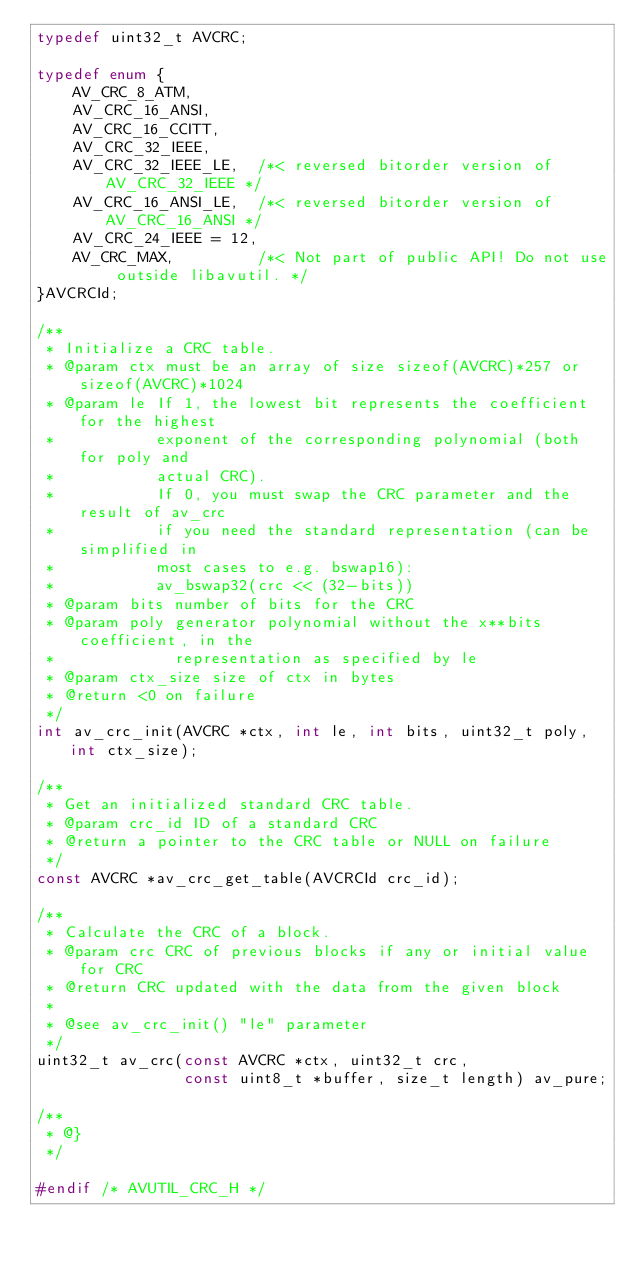Convert code to text. <code><loc_0><loc_0><loc_500><loc_500><_C_>typedef uint32_t AVCRC;

typedef enum {
    AV_CRC_8_ATM,
    AV_CRC_16_ANSI,
    AV_CRC_16_CCITT,
    AV_CRC_32_IEEE,
    AV_CRC_32_IEEE_LE,  /*< reversed bitorder version of AV_CRC_32_IEEE */
    AV_CRC_16_ANSI_LE,  /*< reversed bitorder version of AV_CRC_16_ANSI */
    AV_CRC_24_IEEE = 12,
    AV_CRC_MAX,         /*< Not part of public API! Do not use outside libavutil. */
}AVCRCId;

/**
 * Initialize a CRC table.
 * @param ctx must be an array of size sizeof(AVCRC)*257 or sizeof(AVCRC)*1024
 * @param le If 1, the lowest bit represents the coefficient for the highest
 *           exponent of the corresponding polynomial (both for poly and
 *           actual CRC).
 *           If 0, you must swap the CRC parameter and the result of av_crc
 *           if you need the standard representation (can be simplified in
 *           most cases to e.g. bswap16):
 *           av_bswap32(crc << (32-bits))
 * @param bits number of bits for the CRC
 * @param poly generator polynomial without the x**bits coefficient, in the
 *             representation as specified by le
 * @param ctx_size size of ctx in bytes
 * @return <0 on failure
 */
int av_crc_init(AVCRC *ctx, int le, int bits, uint32_t poly, int ctx_size);

/**
 * Get an initialized standard CRC table.
 * @param crc_id ID of a standard CRC
 * @return a pointer to the CRC table or NULL on failure
 */
const AVCRC *av_crc_get_table(AVCRCId crc_id);

/**
 * Calculate the CRC of a block.
 * @param crc CRC of previous blocks if any or initial value for CRC
 * @return CRC updated with the data from the given block
 *
 * @see av_crc_init() "le" parameter
 */
uint32_t av_crc(const AVCRC *ctx, uint32_t crc,
                const uint8_t *buffer, size_t length) av_pure;

/**
 * @}
 */

#endif /* AVUTIL_CRC_H */
</code> 